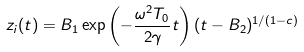Convert formula to latex. <formula><loc_0><loc_0><loc_500><loc_500>z _ { i } ( t ) = B _ { 1 } \exp \left ( - \frac { \omega ^ { 2 } T _ { 0 } } { 2 \gamma } t \right ) ( t - B _ { 2 } ) ^ { 1 / ( 1 - c ) }</formula> 